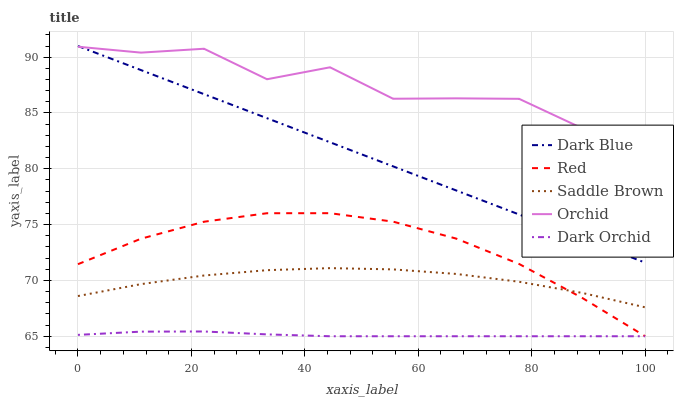Does Dark Blue have the minimum area under the curve?
Answer yes or no. No. Does Dark Blue have the maximum area under the curve?
Answer yes or no. No. Is Saddle Brown the smoothest?
Answer yes or no. No. Is Saddle Brown the roughest?
Answer yes or no. No. Does Dark Blue have the lowest value?
Answer yes or no. No. Does Saddle Brown have the highest value?
Answer yes or no. No. Is Red less than Orchid?
Answer yes or no. Yes. Is Orchid greater than Red?
Answer yes or no. Yes. Does Red intersect Orchid?
Answer yes or no. No. 